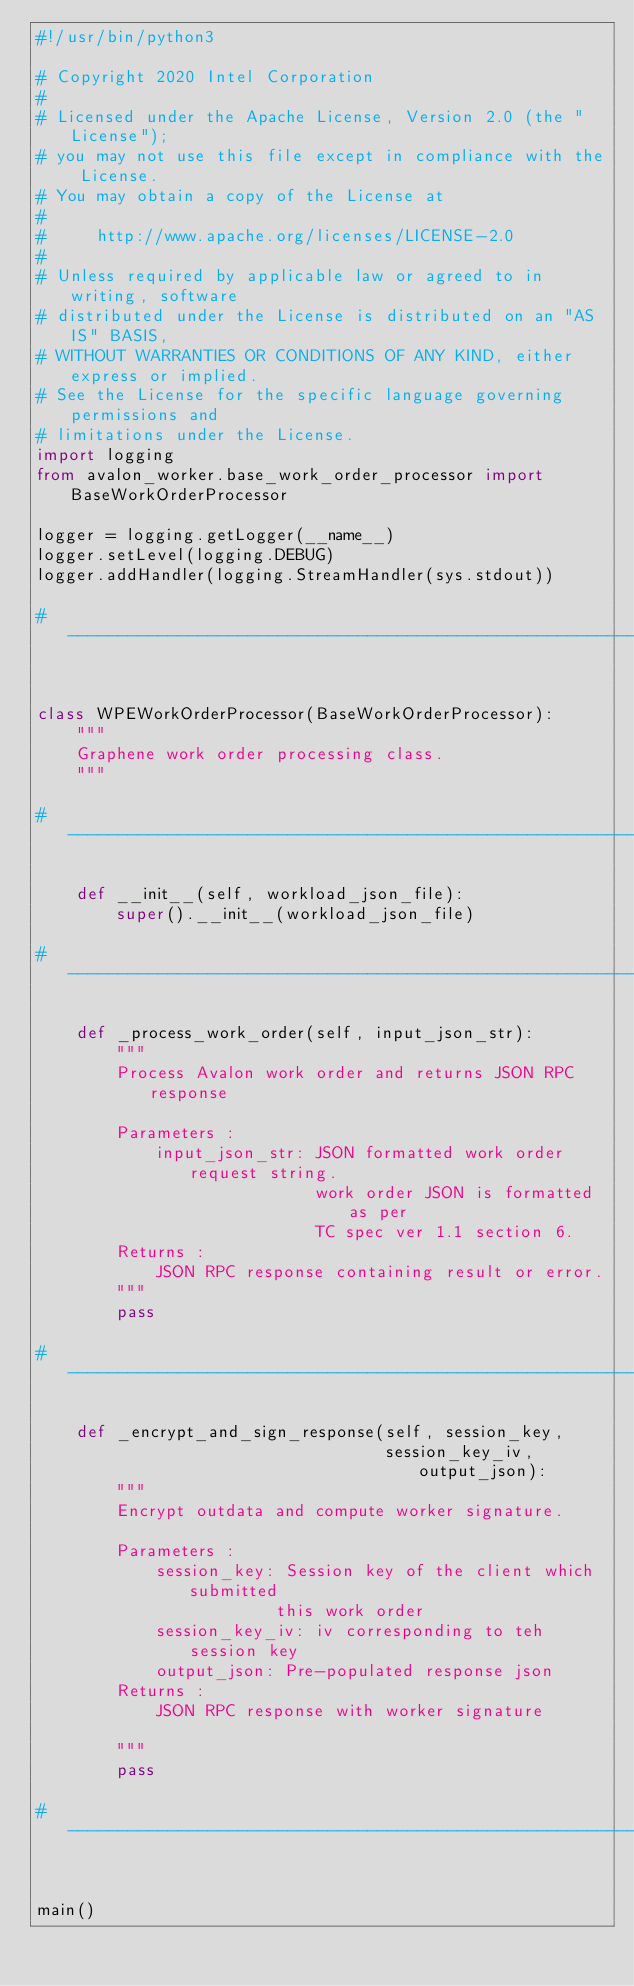<code> <loc_0><loc_0><loc_500><loc_500><_Python_>#!/usr/bin/python3

# Copyright 2020 Intel Corporation
#
# Licensed under the Apache License, Version 2.0 (the "License");
# you may not use this file except in compliance with the License.
# You may obtain a copy of the License at
#
#     http://www.apache.org/licenses/LICENSE-2.0
#
# Unless required by applicable law or agreed to in writing, software
# distributed under the License is distributed on an "AS IS" BASIS,
# WITHOUT WARRANTIES OR CONDITIONS OF ANY KIND, either express or implied.
# See the License for the specific language governing permissions and
# limitations under the License.
import logging
from avalon_worker.base_work_order_processor import BaseWorkOrderProcessor

logger = logging.getLogger(__name__)
logger.setLevel(logging.DEBUG)
logger.addHandler(logging.StreamHandler(sys.stdout))

# -------------------------------------------------------------------------


class WPEWorkOrderProcessor(BaseWorkOrderProcessor):
    """
    Graphene work order processing class.
    """

# -------------------------------------------------------------------------

    def __init__(self, workload_json_file):
        super().__init__(workload_json_file)

# -------------------------------------------------------------------------

    def _process_work_order(self, input_json_str):
        """
        Process Avalon work order and returns JSON RPC response

        Parameters :
            input_json_str: JSON formatted work order request string.
                            work order JSON is formatted as per
                            TC spec ver 1.1 section 6.
        Returns :
            JSON RPC response containing result or error.
        """
        pass

# -------------------------------------------------------------------------

    def _encrypt_and_sign_response(self, session_key,
                                   session_key_iv, output_json):
        """
        Encrypt outdata and compute worker signature.

        Parameters :
            session_key: Session key of the client which submitted
                        this work order
            session_key_iv: iv corresponding to teh session key
            output_json: Pre-populated response json
        Returns :
            JSON RPC response with worker signature

        """
        pass

# -------------------------------------------------------------------------


main()
</code> 